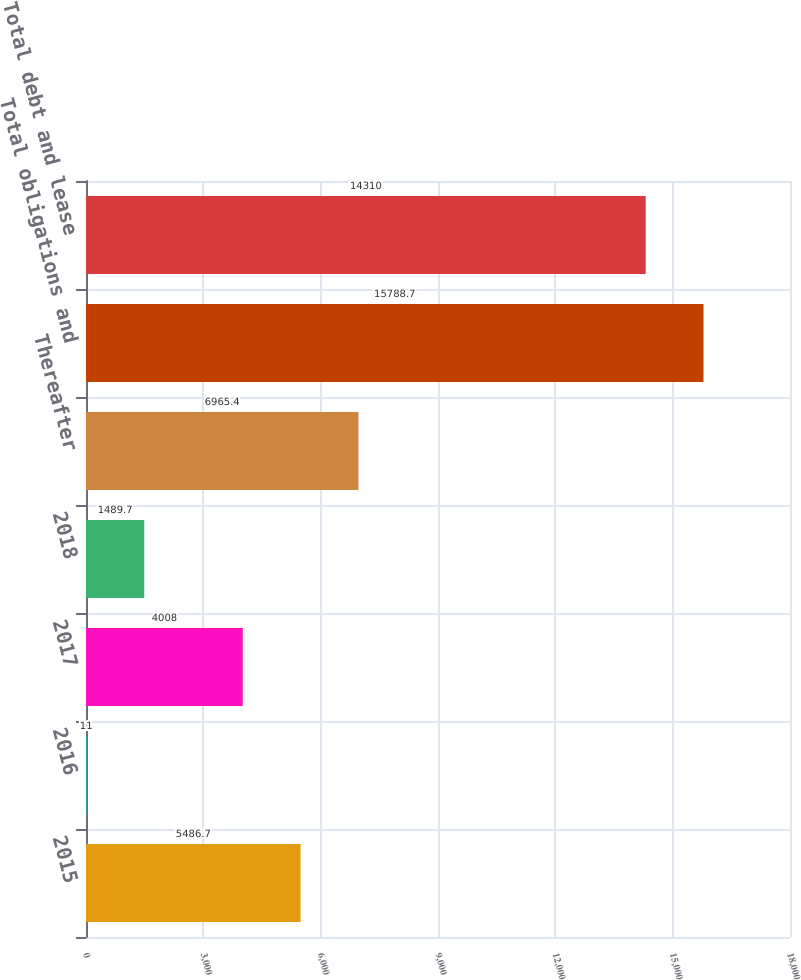Convert chart to OTSL. <chart><loc_0><loc_0><loc_500><loc_500><bar_chart><fcel>2015<fcel>2016<fcel>2017<fcel>2018<fcel>Thereafter<fcel>Total obligations and<fcel>Total debt and lease<nl><fcel>5486.7<fcel>11<fcel>4008<fcel>1489.7<fcel>6965.4<fcel>15788.7<fcel>14310<nl></chart> 